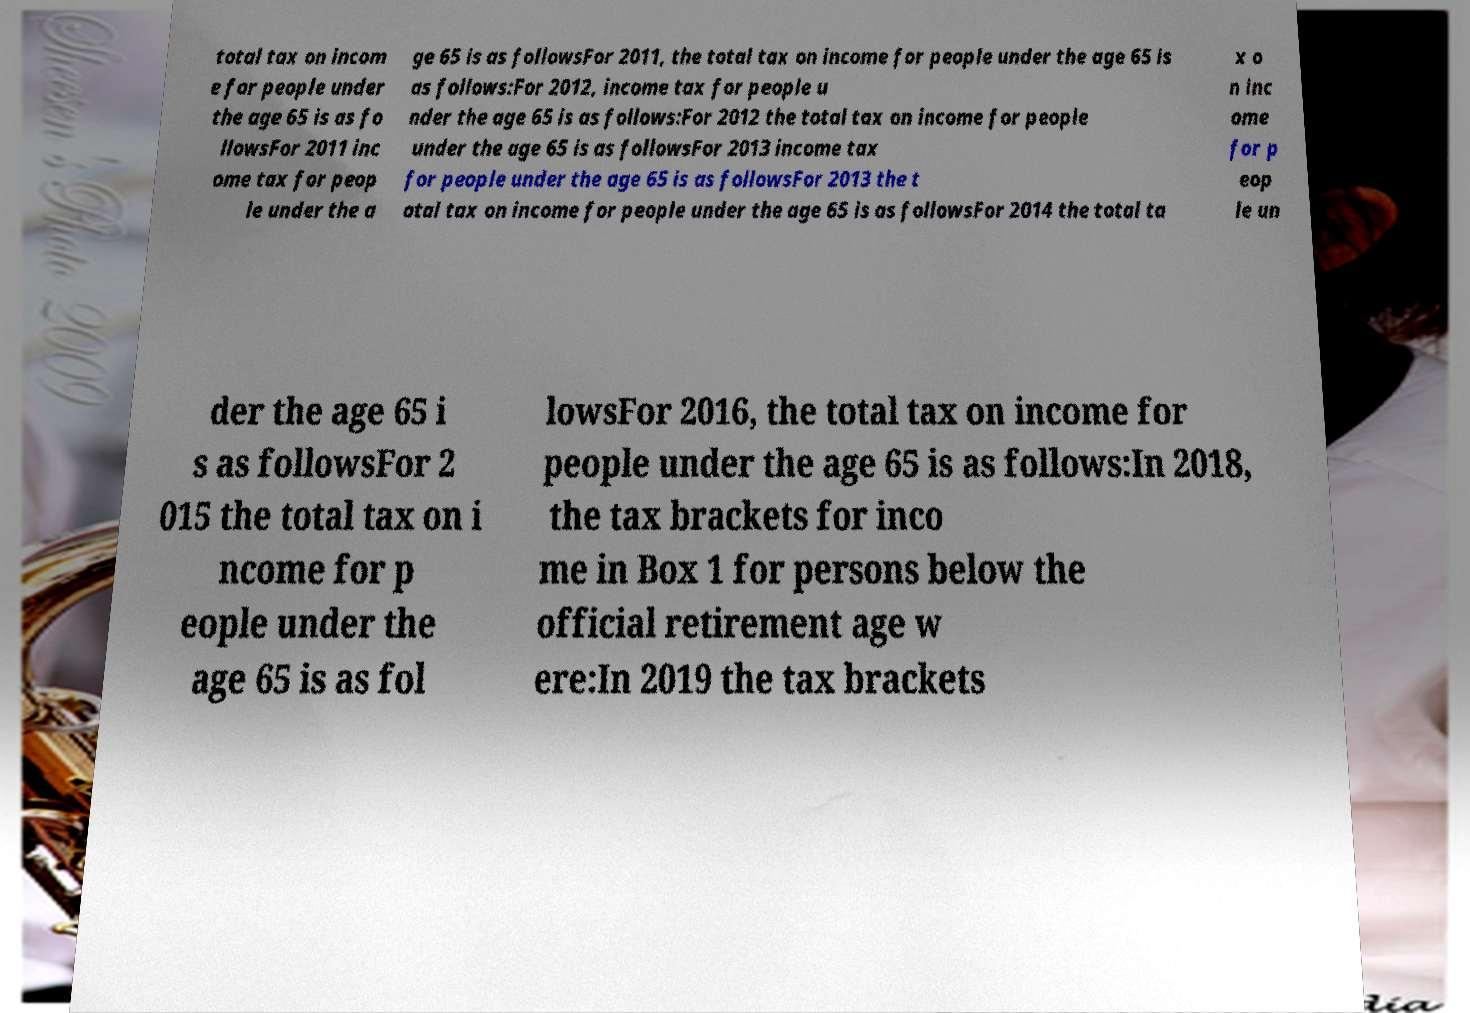There's text embedded in this image that I need extracted. Can you transcribe it verbatim? total tax on incom e for people under the age 65 is as fo llowsFor 2011 inc ome tax for peop le under the a ge 65 is as followsFor 2011, the total tax on income for people under the age 65 is as follows:For 2012, income tax for people u nder the age 65 is as follows:For 2012 the total tax on income for people under the age 65 is as followsFor 2013 income tax for people under the age 65 is as followsFor 2013 the t otal tax on income for people under the age 65 is as followsFor 2014 the total ta x o n inc ome for p eop le un der the age 65 i s as followsFor 2 015 the total tax on i ncome for p eople under the age 65 is as fol lowsFor 2016, the total tax on income for people under the age 65 is as follows:In 2018, the tax brackets for inco me in Box 1 for persons below the official retirement age w ere:In 2019 the tax brackets 